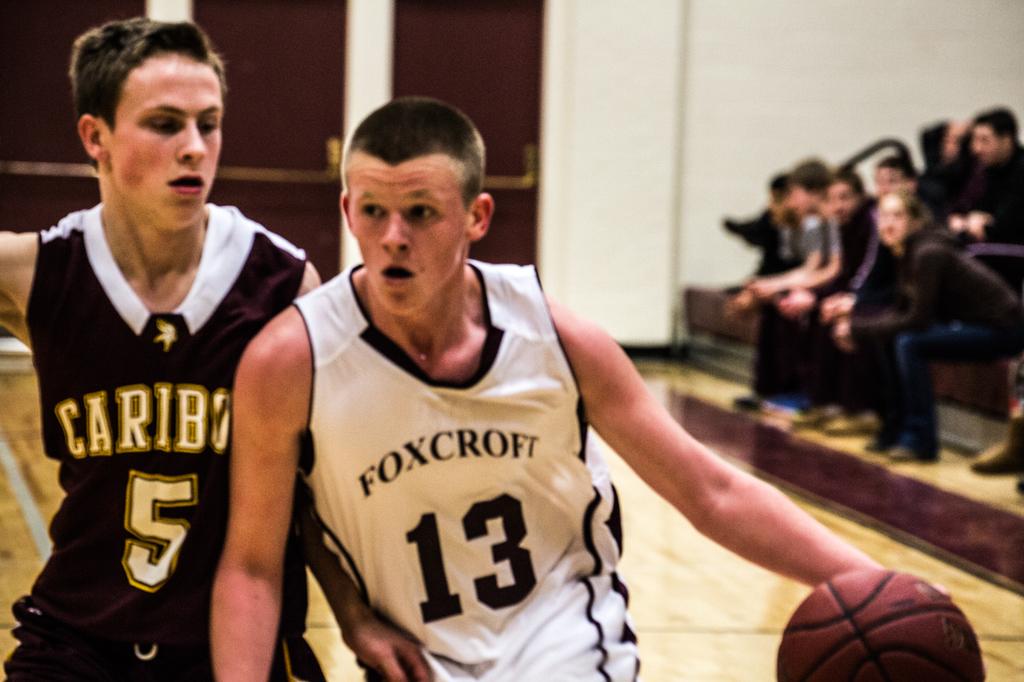What number is on the dark jersey?
Give a very brief answer. 5. 